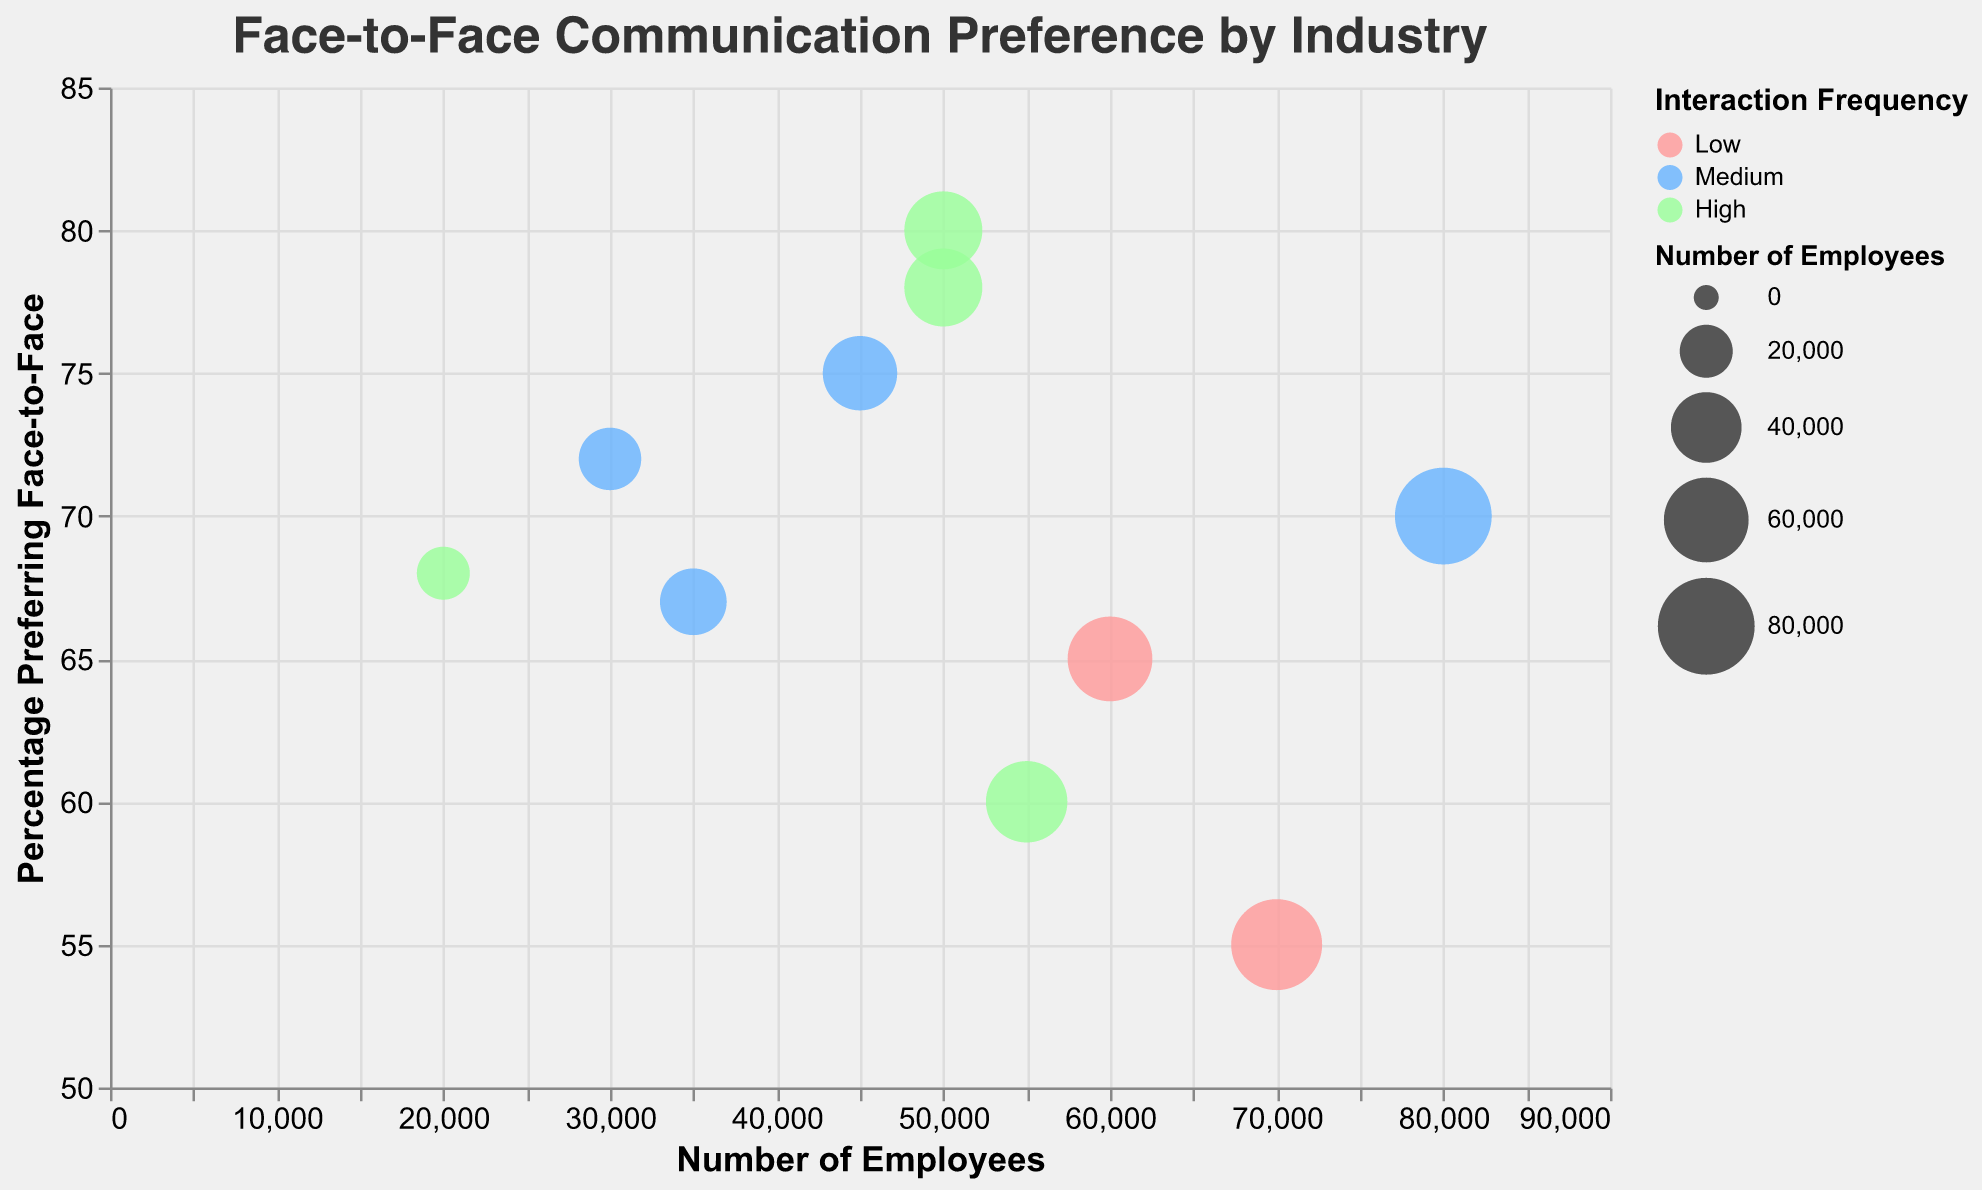How many industries are represented in the plot? Look for the number of distinct data points, as each bubble represents an industry.
Answer: 10 What is the title of the plot? The title is displayed at the top of the plot.
Answer: Face-to-Face Communication Preference by Industry What color represents high interaction frequency? The legend shows that high interaction frequency bubbles are colored green.
Answer: Green Which industry has the highest percentage of people who prefer face-to-face communication? Compare the percentages on the y-axis and identify the highest one, which is 80% for Healthcare.
Answer: Healthcare Which industry has the lowest percentage of people who prefer face-to-face communication? Compare the percentages on the y-axis and identify the lowest one, which is 55% for Technology.
Answer: Technology How many data points have a medium interaction frequency? Count the number of bubbles colored blue, representing medium interaction frequency.
Answer: 5 Which industry has the largest number of employees? Compare the number of employees on the x-axis and identify the highest number, which is 80,000 for Manufacturing.
Answer: Manufacturing Is there any industry with less than 30,000 employees? Check the x-axis values for data points with less than 30,000 employees, which is the Legal industry with 30,000 and the Non-Profit with 20,000.
Answer: Yes, Non-Profit What is the average percentage of people who prefer face-to-face communication in the Education, Legal, and Real Estate industries? Calculate the average: (75 + 72 + 67) / 3 = 71.33
Answer: 71.33 Among the industries categorized with high interaction frequency, which one has the lowest percentage of face-to-face preference? Identify industries with high interaction frequency (green bubbles) and compare their percentages, finding that Retail has 60%.
Answer: Retail 